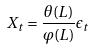<formula> <loc_0><loc_0><loc_500><loc_500>X _ { t } = \frac { \theta ( L ) } { \varphi ( L ) } \epsilon _ { t }</formula> 